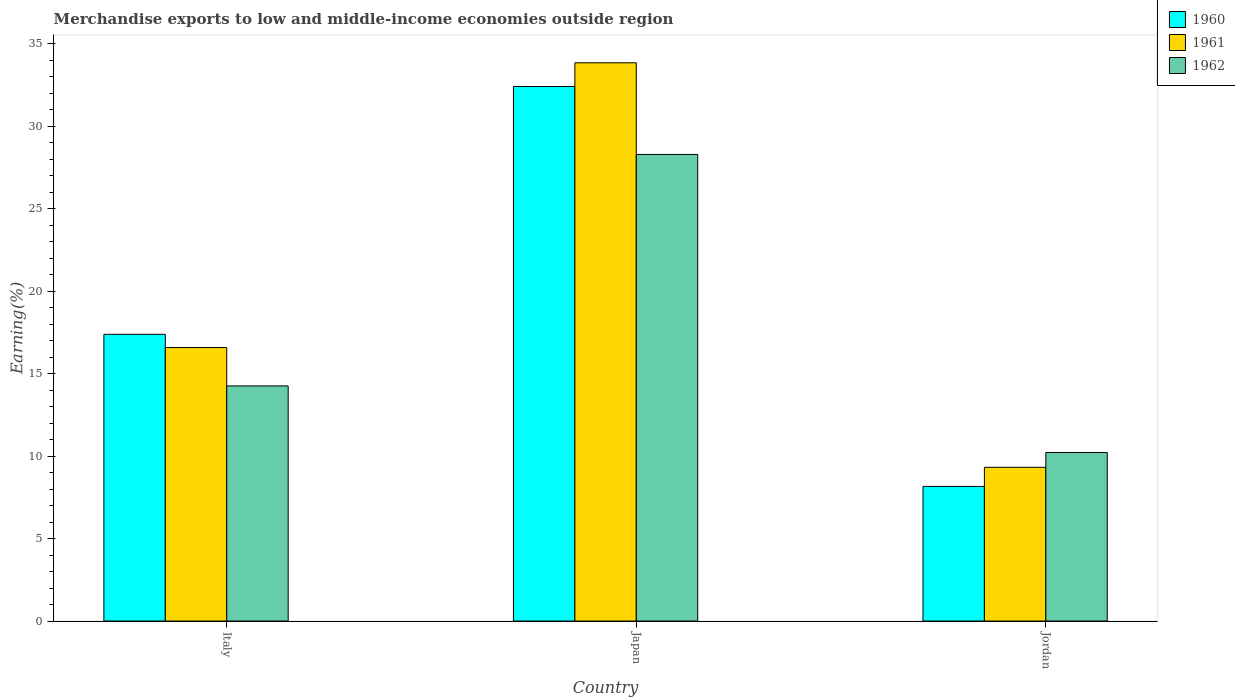How many different coloured bars are there?
Offer a very short reply. 3. Are the number of bars per tick equal to the number of legend labels?
Offer a terse response. Yes. How many bars are there on the 2nd tick from the left?
Your answer should be very brief. 3. How many bars are there on the 1st tick from the right?
Make the answer very short. 3. What is the label of the 2nd group of bars from the left?
Your answer should be very brief. Japan. In how many cases, is the number of bars for a given country not equal to the number of legend labels?
Provide a succinct answer. 0. What is the percentage of amount earned from merchandise exports in 1961 in Japan?
Your answer should be compact. 33.85. Across all countries, what is the maximum percentage of amount earned from merchandise exports in 1960?
Offer a terse response. 32.41. Across all countries, what is the minimum percentage of amount earned from merchandise exports in 1962?
Make the answer very short. 10.22. In which country was the percentage of amount earned from merchandise exports in 1961 minimum?
Keep it short and to the point. Jordan. What is the total percentage of amount earned from merchandise exports in 1962 in the graph?
Ensure brevity in your answer.  52.77. What is the difference between the percentage of amount earned from merchandise exports in 1962 in Italy and that in Jordan?
Your answer should be very brief. 4.04. What is the difference between the percentage of amount earned from merchandise exports in 1960 in Jordan and the percentage of amount earned from merchandise exports in 1961 in Italy?
Keep it short and to the point. -8.42. What is the average percentage of amount earned from merchandise exports in 1960 per country?
Offer a terse response. 19.32. What is the difference between the percentage of amount earned from merchandise exports of/in 1960 and percentage of amount earned from merchandise exports of/in 1961 in Jordan?
Ensure brevity in your answer.  -1.16. What is the ratio of the percentage of amount earned from merchandise exports in 1960 in Italy to that in Jordan?
Your answer should be compact. 2.13. Is the percentage of amount earned from merchandise exports in 1962 in Italy less than that in Japan?
Ensure brevity in your answer.  Yes. What is the difference between the highest and the second highest percentage of amount earned from merchandise exports in 1961?
Provide a succinct answer. -17.27. What is the difference between the highest and the lowest percentage of amount earned from merchandise exports in 1960?
Keep it short and to the point. 24.25. In how many countries, is the percentage of amount earned from merchandise exports in 1961 greater than the average percentage of amount earned from merchandise exports in 1961 taken over all countries?
Your response must be concise. 1. What does the 2nd bar from the left in Italy represents?
Give a very brief answer. 1961. Is it the case that in every country, the sum of the percentage of amount earned from merchandise exports in 1961 and percentage of amount earned from merchandise exports in 1962 is greater than the percentage of amount earned from merchandise exports in 1960?
Offer a very short reply. Yes. How many bars are there?
Your answer should be very brief. 9. Does the graph contain any zero values?
Provide a succinct answer. No. Does the graph contain grids?
Provide a succinct answer. No. Where does the legend appear in the graph?
Give a very brief answer. Top right. How many legend labels are there?
Provide a short and direct response. 3. How are the legend labels stacked?
Offer a terse response. Vertical. What is the title of the graph?
Your answer should be compact. Merchandise exports to low and middle-income economies outside region. What is the label or title of the Y-axis?
Keep it short and to the point. Earning(%). What is the Earning(%) in 1960 in Italy?
Your answer should be compact. 17.38. What is the Earning(%) of 1961 in Italy?
Ensure brevity in your answer.  16.58. What is the Earning(%) in 1962 in Italy?
Make the answer very short. 14.26. What is the Earning(%) of 1960 in Japan?
Keep it short and to the point. 32.41. What is the Earning(%) of 1961 in Japan?
Provide a succinct answer. 33.85. What is the Earning(%) in 1962 in Japan?
Ensure brevity in your answer.  28.29. What is the Earning(%) of 1960 in Jordan?
Offer a terse response. 8.16. What is the Earning(%) in 1961 in Jordan?
Provide a short and direct response. 9.32. What is the Earning(%) in 1962 in Jordan?
Provide a succinct answer. 10.22. Across all countries, what is the maximum Earning(%) of 1960?
Keep it short and to the point. 32.41. Across all countries, what is the maximum Earning(%) of 1961?
Provide a succinct answer. 33.85. Across all countries, what is the maximum Earning(%) in 1962?
Provide a short and direct response. 28.29. Across all countries, what is the minimum Earning(%) of 1960?
Offer a very short reply. 8.16. Across all countries, what is the minimum Earning(%) in 1961?
Your answer should be very brief. 9.32. Across all countries, what is the minimum Earning(%) in 1962?
Give a very brief answer. 10.22. What is the total Earning(%) of 1960 in the graph?
Give a very brief answer. 57.96. What is the total Earning(%) of 1961 in the graph?
Your response must be concise. 59.76. What is the total Earning(%) of 1962 in the graph?
Provide a short and direct response. 52.77. What is the difference between the Earning(%) in 1960 in Italy and that in Japan?
Keep it short and to the point. -15.03. What is the difference between the Earning(%) of 1961 in Italy and that in Japan?
Make the answer very short. -17.27. What is the difference between the Earning(%) in 1962 in Italy and that in Japan?
Keep it short and to the point. -14.04. What is the difference between the Earning(%) of 1960 in Italy and that in Jordan?
Keep it short and to the point. 9.22. What is the difference between the Earning(%) of 1961 in Italy and that in Jordan?
Ensure brevity in your answer.  7.26. What is the difference between the Earning(%) of 1962 in Italy and that in Jordan?
Keep it short and to the point. 4.04. What is the difference between the Earning(%) of 1960 in Japan and that in Jordan?
Keep it short and to the point. 24.25. What is the difference between the Earning(%) in 1961 in Japan and that in Jordan?
Make the answer very short. 24.53. What is the difference between the Earning(%) of 1962 in Japan and that in Jordan?
Provide a succinct answer. 18.07. What is the difference between the Earning(%) of 1960 in Italy and the Earning(%) of 1961 in Japan?
Offer a very short reply. -16.47. What is the difference between the Earning(%) of 1960 in Italy and the Earning(%) of 1962 in Japan?
Your response must be concise. -10.91. What is the difference between the Earning(%) in 1961 in Italy and the Earning(%) in 1962 in Japan?
Offer a terse response. -11.71. What is the difference between the Earning(%) in 1960 in Italy and the Earning(%) in 1961 in Jordan?
Provide a short and direct response. 8.06. What is the difference between the Earning(%) of 1960 in Italy and the Earning(%) of 1962 in Jordan?
Offer a terse response. 7.17. What is the difference between the Earning(%) in 1961 in Italy and the Earning(%) in 1962 in Jordan?
Offer a terse response. 6.36. What is the difference between the Earning(%) in 1960 in Japan and the Earning(%) in 1961 in Jordan?
Provide a short and direct response. 23.09. What is the difference between the Earning(%) in 1960 in Japan and the Earning(%) in 1962 in Jordan?
Offer a very short reply. 22.2. What is the difference between the Earning(%) in 1961 in Japan and the Earning(%) in 1962 in Jordan?
Your response must be concise. 23.63. What is the average Earning(%) of 1960 per country?
Offer a terse response. 19.32. What is the average Earning(%) of 1961 per country?
Your answer should be compact. 19.92. What is the average Earning(%) of 1962 per country?
Keep it short and to the point. 17.59. What is the difference between the Earning(%) of 1960 and Earning(%) of 1961 in Italy?
Keep it short and to the point. 0.8. What is the difference between the Earning(%) in 1960 and Earning(%) in 1962 in Italy?
Your answer should be very brief. 3.13. What is the difference between the Earning(%) in 1961 and Earning(%) in 1962 in Italy?
Keep it short and to the point. 2.33. What is the difference between the Earning(%) in 1960 and Earning(%) in 1961 in Japan?
Your answer should be compact. -1.44. What is the difference between the Earning(%) in 1960 and Earning(%) in 1962 in Japan?
Make the answer very short. 4.12. What is the difference between the Earning(%) of 1961 and Earning(%) of 1962 in Japan?
Give a very brief answer. 5.56. What is the difference between the Earning(%) of 1960 and Earning(%) of 1961 in Jordan?
Ensure brevity in your answer.  -1.16. What is the difference between the Earning(%) in 1960 and Earning(%) in 1962 in Jordan?
Make the answer very short. -2.06. What is the difference between the Earning(%) of 1961 and Earning(%) of 1962 in Jordan?
Give a very brief answer. -0.9. What is the ratio of the Earning(%) in 1960 in Italy to that in Japan?
Your answer should be very brief. 0.54. What is the ratio of the Earning(%) of 1961 in Italy to that in Japan?
Keep it short and to the point. 0.49. What is the ratio of the Earning(%) in 1962 in Italy to that in Japan?
Your response must be concise. 0.5. What is the ratio of the Earning(%) in 1960 in Italy to that in Jordan?
Ensure brevity in your answer.  2.13. What is the ratio of the Earning(%) of 1961 in Italy to that in Jordan?
Your answer should be compact. 1.78. What is the ratio of the Earning(%) of 1962 in Italy to that in Jordan?
Provide a short and direct response. 1.4. What is the ratio of the Earning(%) of 1960 in Japan to that in Jordan?
Your answer should be very brief. 3.97. What is the ratio of the Earning(%) of 1961 in Japan to that in Jordan?
Keep it short and to the point. 3.63. What is the ratio of the Earning(%) in 1962 in Japan to that in Jordan?
Offer a terse response. 2.77. What is the difference between the highest and the second highest Earning(%) of 1960?
Make the answer very short. 15.03. What is the difference between the highest and the second highest Earning(%) in 1961?
Your response must be concise. 17.27. What is the difference between the highest and the second highest Earning(%) in 1962?
Give a very brief answer. 14.04. What is the difference between the highest and the lowest Earning(%) of 1960?
Keep it short and to the point. 24.25. What is the difference between the highest and the lowest Earning(%) of 1961?
Give a very brief answer. 24.53. What is the difference between the highest and the lowest Earning(%) of 1962?
Keep it short and to the point. 18.07. 